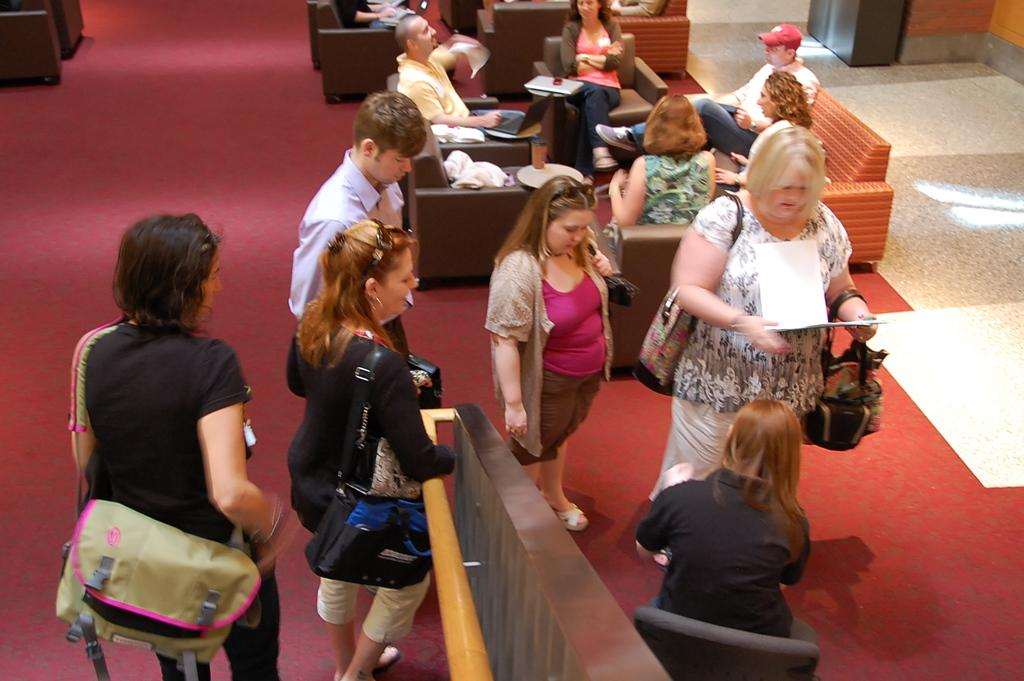What are the people in the image doing? Some people are standing, and some are sitting in the image. What type of furniture is present in the image? There is a sofa chair in the image. What color is the crayon being used to draw in the image? There is no crayon or drawing activity present in the image. 